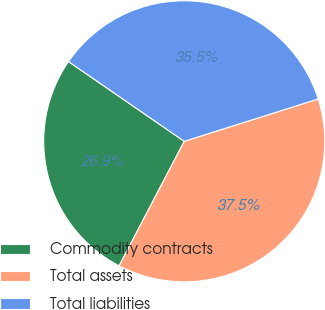<chart> <loc_0><loc_0><loc_500><loc_500><pie_chart><fcel>Commodity contracts<fcel>Total assets<fcel>Total liabilities<nl><fcel>26.94%<fcel>37.54%<fcel>35.53%<nl></chart> 